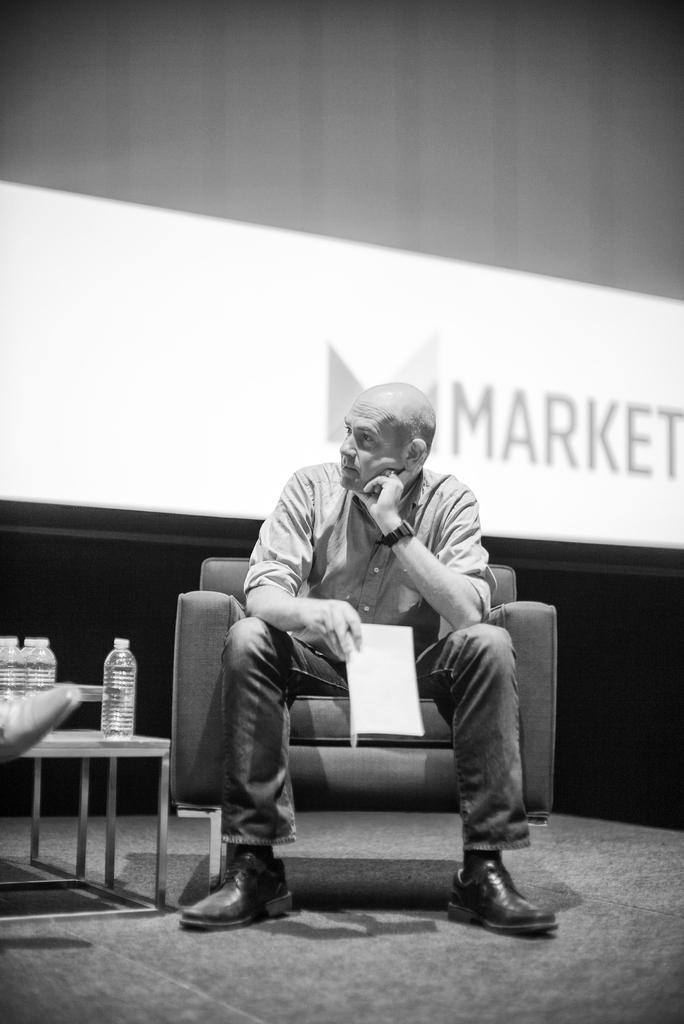Please provide a concise description of this image. In this picture we can see a man holding paper in his hand and siting on chair and beside to them we have bottles with water in it on table and in the background we can see wall, screen. 